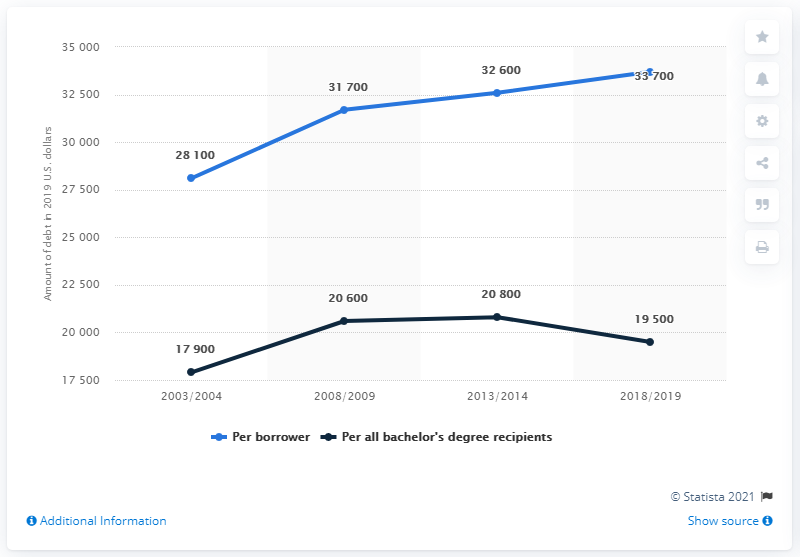Specify some key components in this picture. The blue line reached its peak in the year 2018/2019. The gap between two lines was largest in the year 2018/2019. 